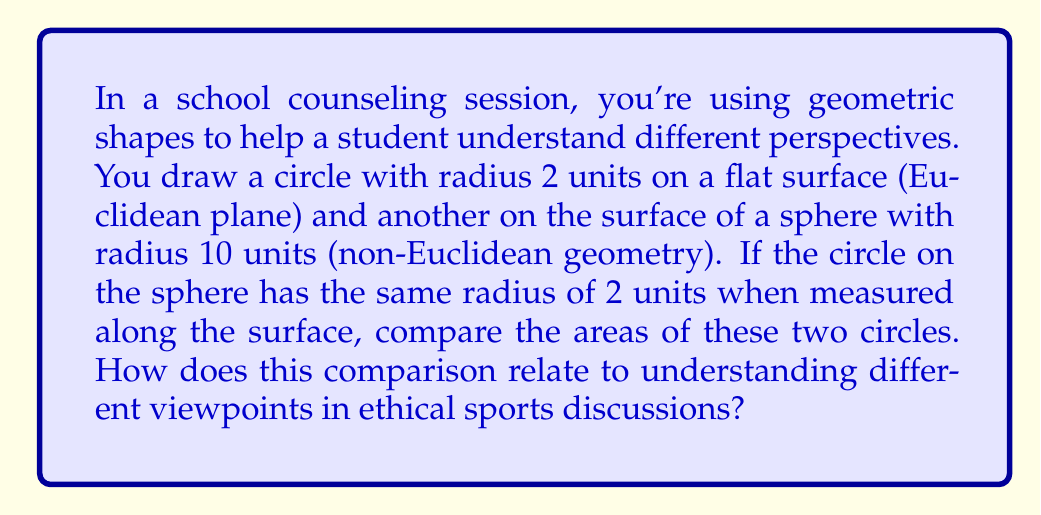Can you answer this question? Let's approach this step-by-step:

1. Area of the circle in Euclidean geometry:
   The formula for the area of a circle in Euclidean geometry is $A = \pi r^2$
   With radius $r = 2$, the area is:
   $$A_E = \pi (2)^2 = 4\pi \approx 12.57$$

2. Area of the circle on a sphere (non-Euclidean geometry):
   The formula for the area of a circle on a sphere with radius R is:
   $$A = 2\pi R^2 \left(1 - \cos\frac{r}{R}\right)$$
   Where $r$ is the radius of the circle measured along the surface, and $R$ is the radius of the sphere.

   Here, $r = 2$ and $R = 10$:
   $$A_S = 2\pi (10)^2 \left(1 - \cos\frac{2}{10}\right)$$
   $$A_S = 200\pi \left(1 - \cos(0.2)\right) \approx 12.31$$

3. Comparison:
   The area of the circle on the sphere ($A_S \approx 12.31$) is slightly smaller than the area of the circle on the flat plane ($A_E \approx 12.57$).

4. Relation to ethical sports discussions:
   This comparison demonstrates that the same concept (a circle with radius 2) can yield different results depending on the context (flat plane vs. sphere). Similarly, in ethical sports discussions, the same situation might be viewed differently depending on the perspective or context, emphasizing the importance of considering multiple viewpoints when making ethical judgments in sports.
Answer: The circle on the sphere has a slightly smaller area (approx. 12.31 square units) compared to the Euclidean circle (approx. 12.57 square units), illustrating how context affects outcomes, similar to ethical considerations in sports. 